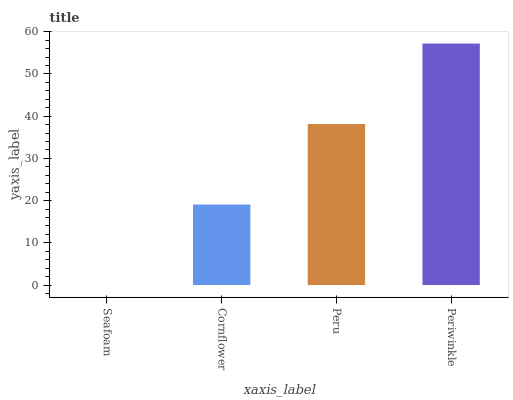Is Seafoam the minimum?
Answer yes or no. Yes. Is Periwinkle the maximum?
Answer yes or no. Yes. Is Cornflower the minimum?
Answer yes or no. No. Is Cornflower the maximum?
Answer yes or no. No. Is Cornflower greater than Seafoam?
Answer yes or no. Yes. Is Seafoam less than Cornflower?
Answer yes or no. Yes. Is Seafoam greater than Cornflower?
Answer yes or no. No. Is Cornflower less than Seafoam?
Answer yes or no. No. Is Peru the high median?
Answer yes or no. Yes. Is Cornflower the low median?
Answer yes or no. Yes. Is Cornflower the high median?
Answer yes or no. No. Is Seafoam the low median?
Answer yes or no. No. 